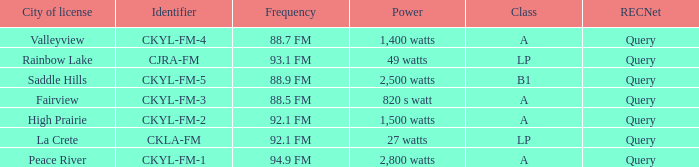What is the frequency that has a fairview city of license 88.5 FM. 